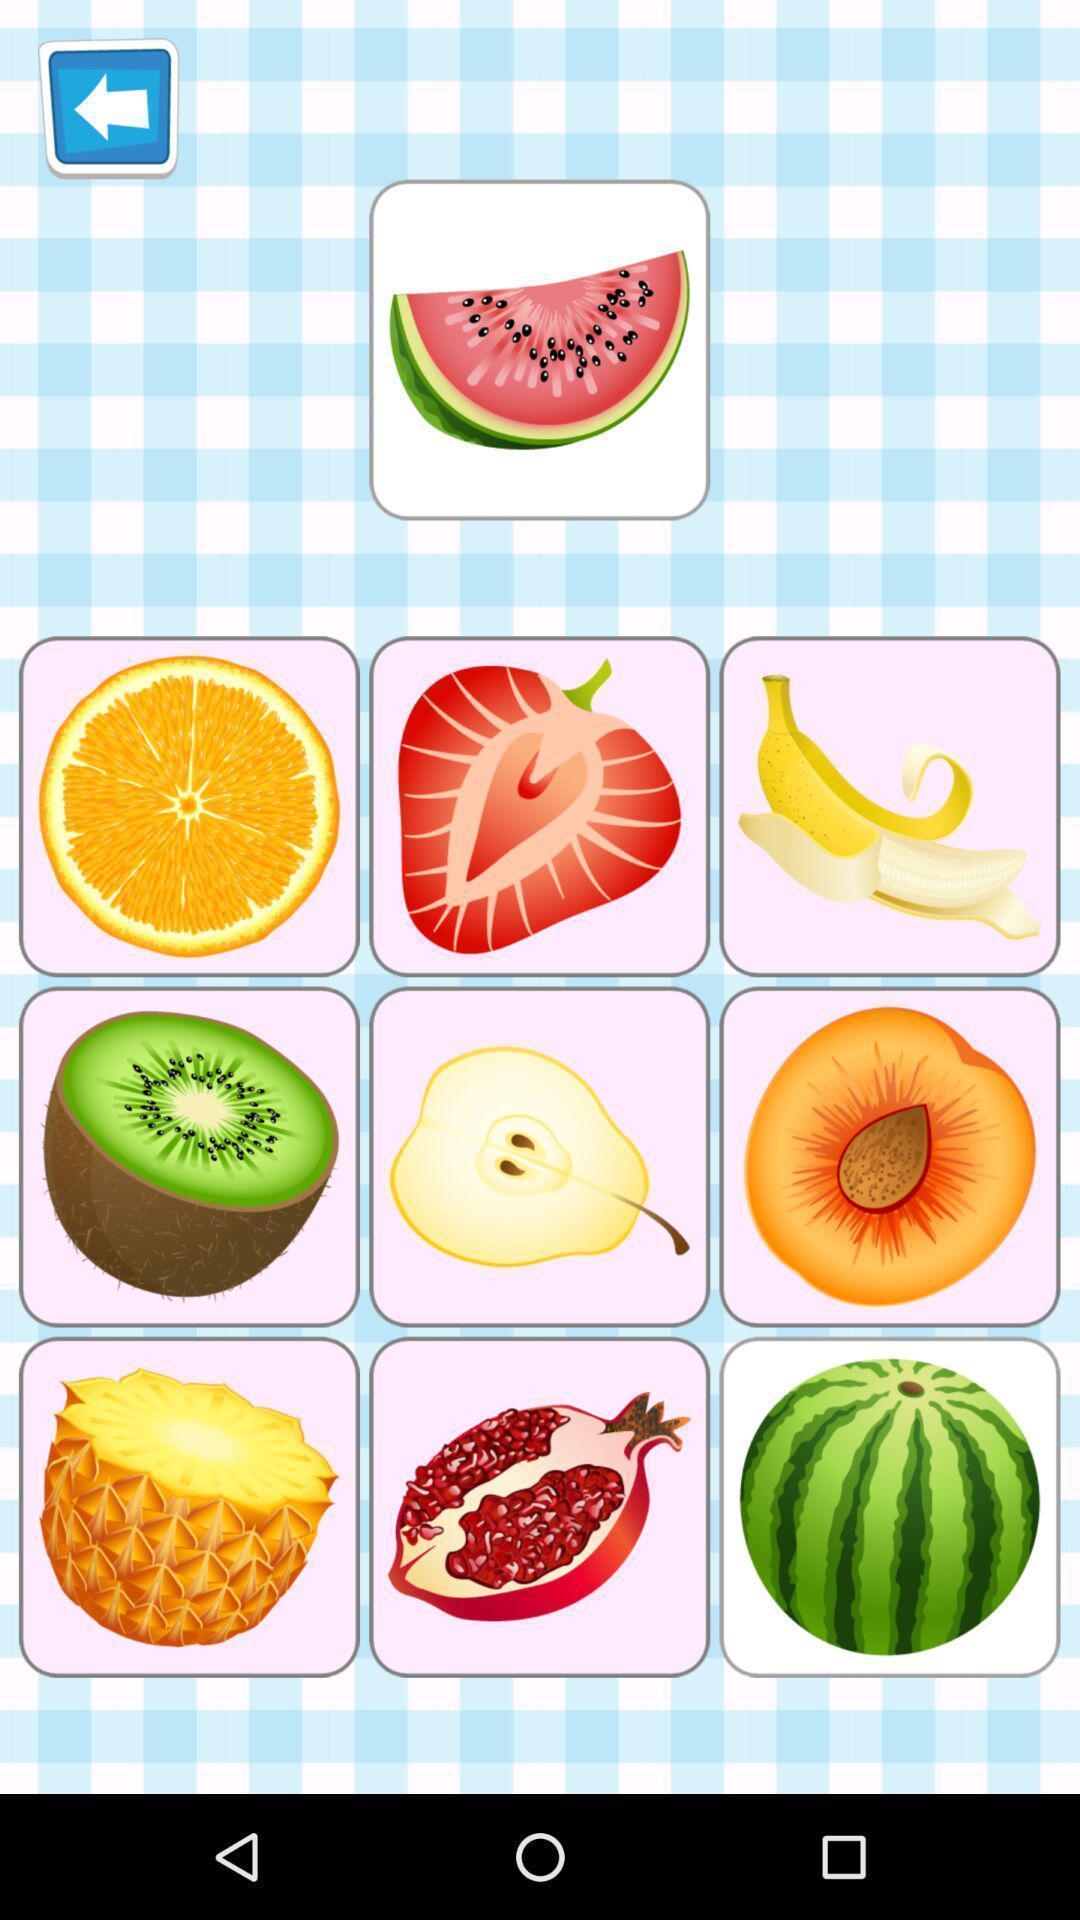Please provide a description for this image. Screen showing page of an game application. 